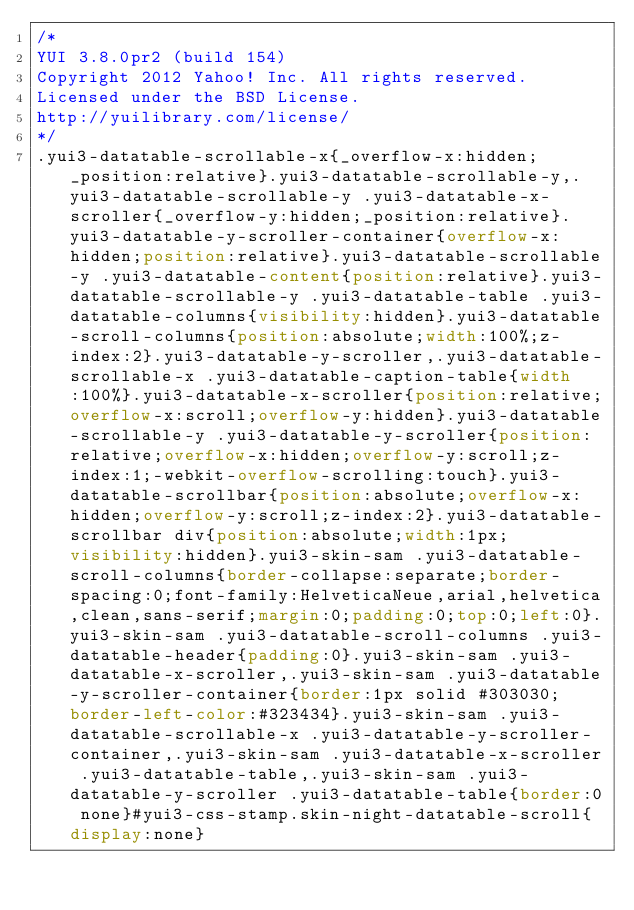<code> <loc_0><loc_0><loc_500><loc_500><_CSS_>/*
YUI 3.8.0pr2 (build 154)
Copyright 2012 Yahoo! Inc. All rights reserved.
Licensed under the BSD License.
http://yuilibrary.com/license/
*/
.yui3-datatable-scrollable-x{_overflow-x:hidden;_position:relative}.yui3-datatable-scrollable-y,.yui3-datatable-scrollable-y .yui3-datatable-x-scroller{_overflow-y:hidden;_position:relative}.yui3-datatable-y-scroller-container{overflow-x:hidden;position:relative}.yui3-datatable-scrollable-y .yui3-datatable-content{position:relative}.yui3-datatable-scrollable-y .yui3-datatable-table .yui3-datatable-columns{visibility:hidden}.yui3-datatable-scroll-columns{position:absolute;width:100%;z-index:2}.yui3-datatable-y-scroller,.yui3-datatable-scrollable-x .yui3-datatable-caption-table{width:100%}.yui3-datatable-x-scroller{position:relative;overflow-x:scroll;overflow-y:hidden}.yui3-datatable-scrollable-y .yui3-datatable-y-scroller{position:relative;overflow-x:hidden;overflow-y:scroll;z-index:1;-webkit-overflow-scrolling:touch}.yui3-datatable-scrollbar{position:absolute;overflow-x:hidden;overflow-y:scroll;z-index:2}.yui3-datatable-scrollbar div{position:absolute;width:1px;visibility:hidden}.yui3-skin-sam .yui3-datatable-scroll-columns{border-collapse:separate;border-spacing:0;font-family:HelveticaNeue,arial,helvetica,clean,sans-serif;margin:0;padding:0;top:0;left:0}.yui3-skin-sam .yui3-datatable-scroll-columns .yui3-datatable-header{padding:0}.yui3-skin-sam .yui3-datatable-x-scroller,.yui3-skin-sam .yui3-datatable-y-scroller-container{border:1px solid #303030;border-left-color:#323434}.yui3-skin-sam .yui3-datatable-scrollable-x .yui3-datatable-y-scroller-container,.yui3-skin-sam .yui3-datatable-x-scroller .yui3-datatable-table,.yui3-skin-sam .yui3-datatable-y-scroller .yui3-datatable-table{border:0 none}#yui3-css-stamp.skin-night-datatable-scroll{display:none}
</code> 